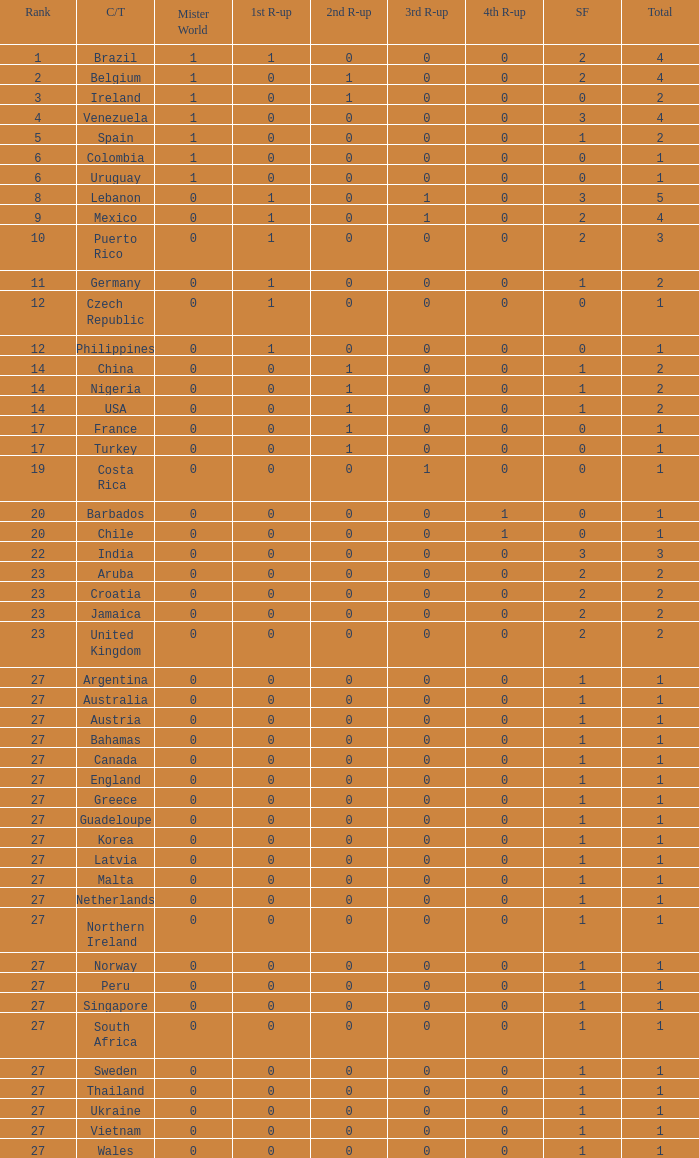What is the number of 1st runner up values for Jamaica? 1.0. 